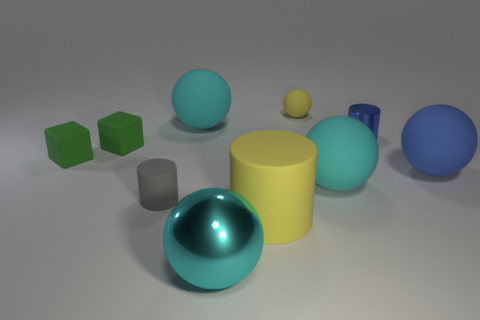Subtract all green cylinders. How many cyan spheres are left? 3 Subtract all blue balls. How many balls are left? 4 Subtract all small rubber spheres. How many spheres are left? 4 Subtract all brown spheres. Subtract all brown cylinders. How many spheres are left? 5 Subtract all cylinders. How many objects are left? 7 Add 6 small spheres. How many small spheres are left? 7 Add 2 big yellow matte objects. How many big yellow matte objects exist? 3 Subtract 0 brown cylinders. How many objects are left? 10 Subtract all blue rubber cylinders. Subtract all tiny blue shiny cylinders. How many objects are left? 9 